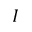Convert formula to latex. <formula><loc_0><loc_0><loc_500><loc_500>I</formula> 